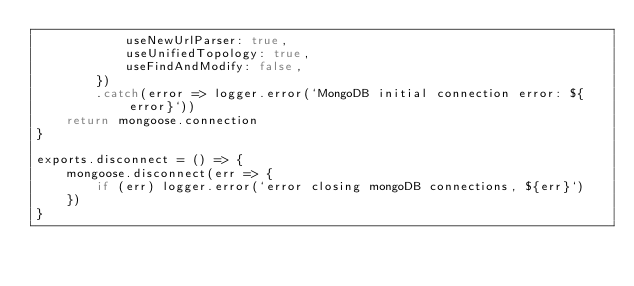<code> <loc_0><loc_0><loc_500><loc_500><_JavaScript_>            useNewUrlParser: true,
            useUnifiedTopology: true,
            useFindAndModify: false,
        })
        .catch(error => logger.error(`MongoDB initial connection error: ${error}`))
    return mongoose.connection
}

exports.disconnect = () => {
    mongoose.disconnect(err => {
        if (err) logger.error(`error closing mongoDB connections, ${err}`)
    })
}
</code> 